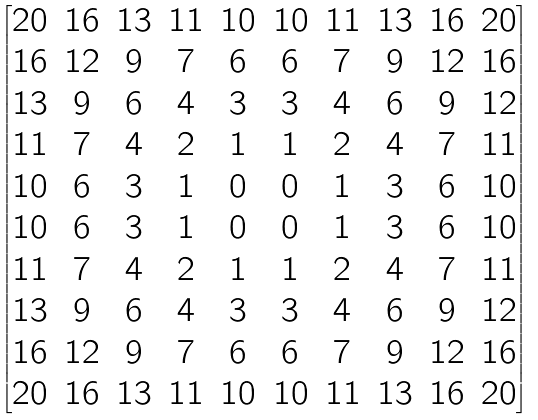Convert formula to latex. <formula><loc_0><loc_0><loc_500><loc_500>\begin{bmatrix} 2 0 & 1 6 & 1 3 & 1 1 & 1 0 & 1 0 & 1 1 & 1 3 & 1 6 & 2 0 \\ 1 6 & 1 2 & 9 & 7 & 6 & 6 & 7 & 9 & 1 2 & 1 6 \\ 1 3 & 9 & 6 & 4 & 3 & 3 & 4 & 6 & 9 & 1 2 \\ 1 1 & 7 & 4 & 2 & 1 & 1 & 2 & 4 & 7 & 1 1 \\ 1 0 & 6 & 3 & 1 & 0 & 0 & 1 & 3 & 6 & 1 0 \\ 1 0 & 6 & 3 & 1 & 0 & 0 & 1 & 3 & 6 & 1 0 \\ 1 1 & 7 & 4 & 2 & 1 & 1 & 2 & 4 & 7 & 1 1 \\ 1 3 & 9 & 6 & 4 & 3 & 3 & 4 & 6 & 9 & 1 2 \\ 1 6 & 1 2 & 9 & 7 & 6 & 6 & 7 & 9 & 1 2 & 1 6 \\ 2 0 & 1 6 & 1 3 & 1 1 & 1 0 & 1 0 & 1 1 & 1 3 & 1 6 & 2 0 \end{bmatrix}</formula> 